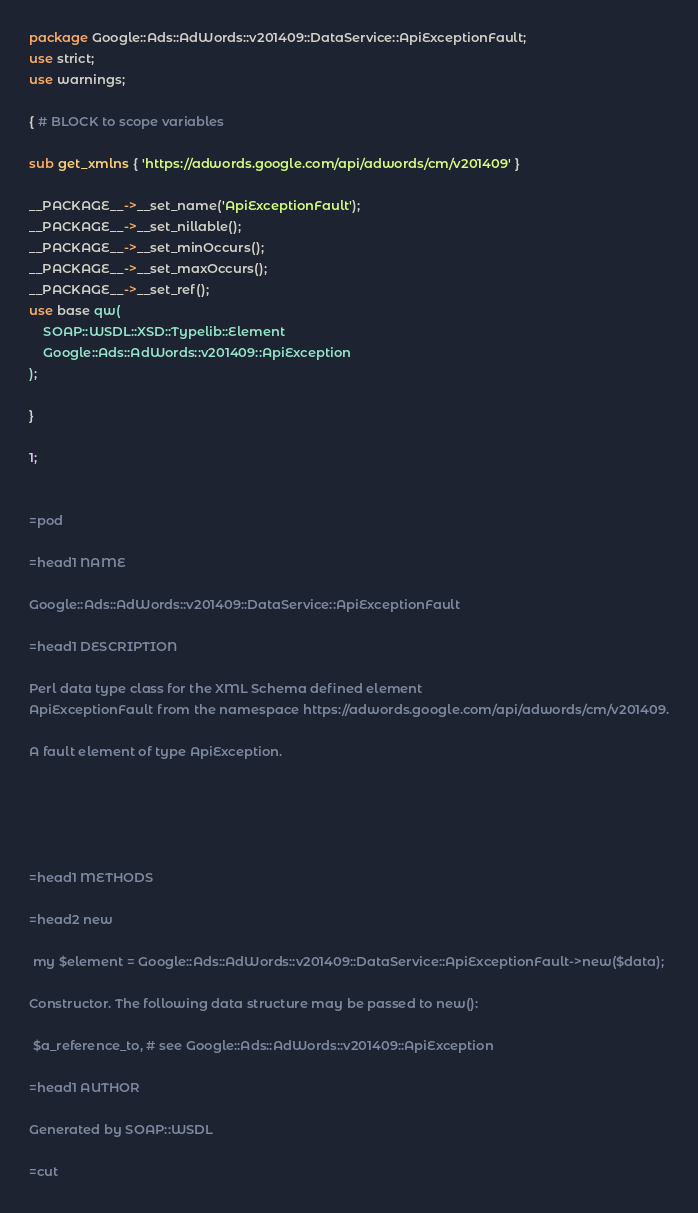<code> <loc_0><loc_0><loc_500><loc_500><_Perl_>
package Google::Ads::AdWords::v201409::DataService::ApiExceptionFault;
use strict;
use warnings;

{ # BLOCK to scope variables

sub get_xmlns { 'https://adwords.google.com/api/adwords/cm/v201409' }

__PACKAGE__->__set_name('ApiExceptionFault');
__PACKAGE__->__set_nillable();
__PACKAGE__->__set_minOccurs();
__PACKAGE__->__set_maxOccurs();
__PACKAGE__->__set_ref();
use base qw(
    SOAP::WSDL::XSD::Typelib::Element
    Google::Ads::AdWords::v201409::ApiException
);

}

1;


=pod

=head1 NAME

Google::Ads::AdWords::v201409::DataService::ApiExceptionFault

=head1 DESCRIPTION

Perl data type class for the XML Schema defined element
ApiExceptionFault from the namespace https://adwords.google.com/api/adwords/cm/v201409.

A fault element of type ApiException. 





=head1 METHODS

=head2 new

 my $element = Google::Ads::AdWords::v201409::DataService::ApiExceptionFault->new($data);

Constructor. The following data structure may be passed to new():

 $a_reference_to, # see Google::Ads::AdWords::v201409::ApiException

=head1 AUTHOR

Generated by SOAP::WSDL

=cut

</code> 